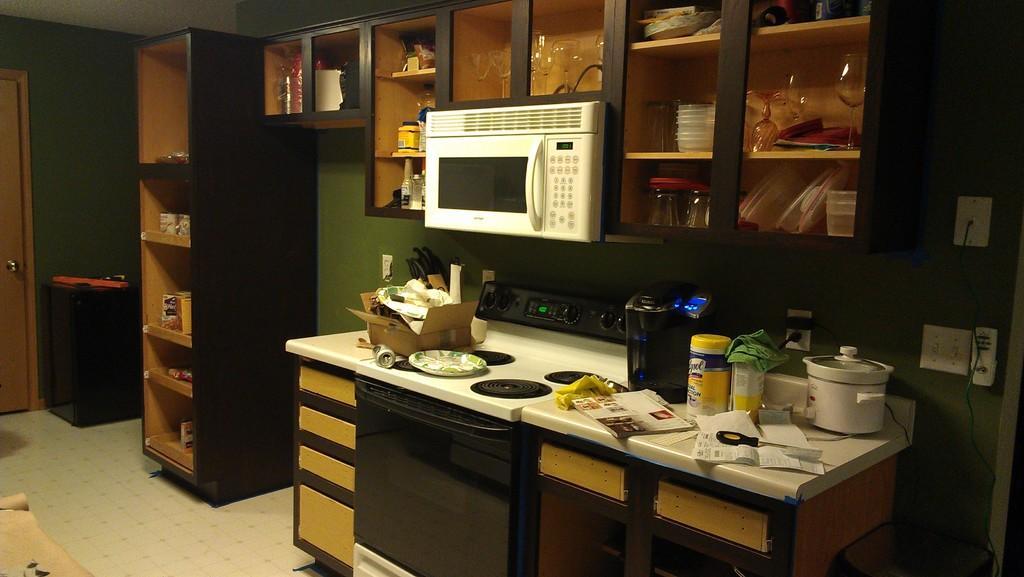In one or two sentences, can you explain what this image depicts? In this image, we can see the interior view of a kitchen. We can see some shelves with objects. We can see the kitchen platform with some objects like a cooker and some posters. We can see the wall with some objects. We can see an oven and the ground with some objects. We can see the gas stove and a door. 